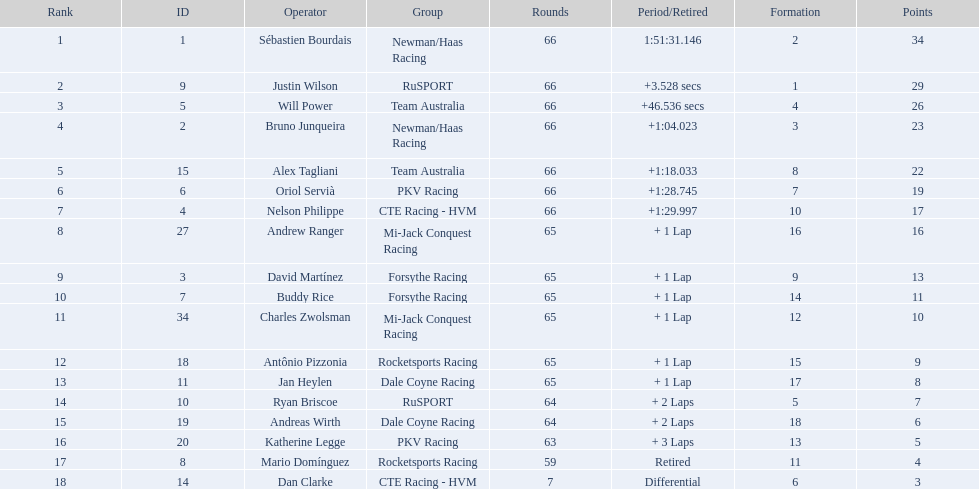What drivers started in the top 10? Sébastien Bourdais, Justin Wilson, Will Power, Bruno Junqueira, Alex Tagliani, Oriol Servià, Nelson Philippe, Ryan Briscoe, Dan Clarke. Which of those drivers completed all 66 laps? Sébastien Bourdais, Justin Wilson, Will Power, Bruno Junqueira, Alex Tagliani, Oriol Servià, Nelson Philippe. Whom of these did not drive for team australia? Sébastien Bourdais, Justin Wilson, Bruno Junqueira, Oriol Servià, Nelson Philippe. Which of these drivers finished more then a minuet after the winner? Bruno Junqueira, Oriol Servià, Nelson Philippe. Which of these drivers had the highest car number? Oriol Servià. 